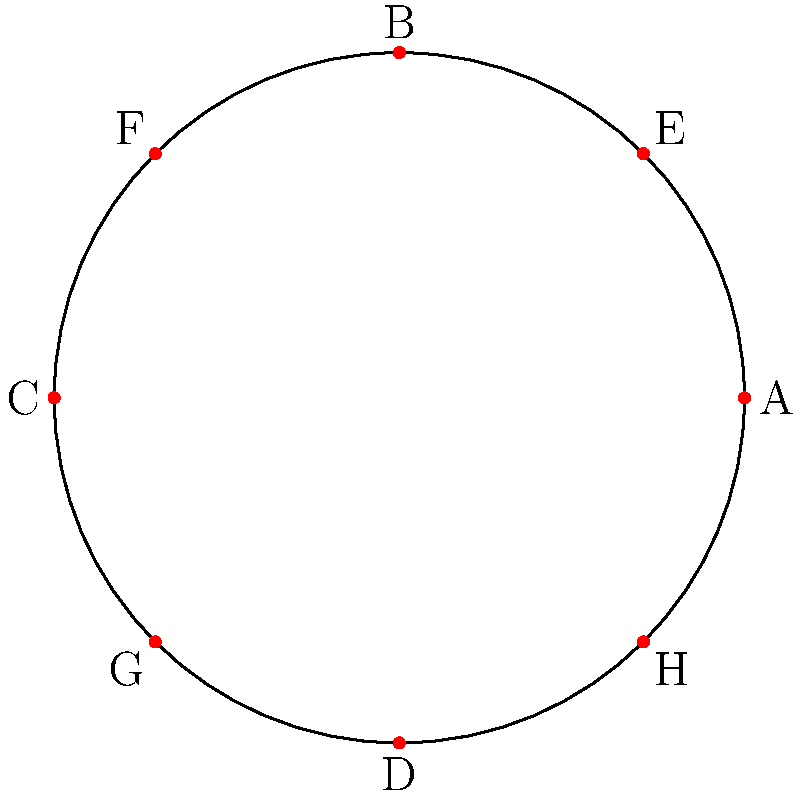In a circular city district with a radius of 5 km, eight polling stations are placed as shown in the diagram. The stations are located at points A, B, C, D, E, F, G, and H. If the polar coordinates of station E are $(r, \theta)$, what is the value of $\theta$ in radians? To solve this problem, let's follow these steps:

1) First, we need to understand what polar coordinates are. In polar coordinates, a point is described by its distance from the origin (r) and the angle ($\theta$) from the positive x-axis.

2) We're given that the radius of the circle is 5 km, so $r = 5$ for all points on the circle.

3) Looking at the diagram, we can see that point E is in the first quadrant, and it appears to be halfway between the positive x-axis and the positive y-axis.

4) In a full circle, there are $2\pi$ radians. A quarter of a circle (90 degrees) is therefore $\frac{\pi}{2}$ radians.

5) Since E is halfway between 0 and $\frac{\pi}{2}$, its angle must be half of $\frac{\pi}{2}$.

6) We can calculate this as:

   $$\theta = \frac{1}{2} \cdot \frac{\pi}{2} = \frac{\pi}{4}$$

7) We can verify this by noting that the x and y coordinates of E appear to be equal and positive, which is consistent with an angle of $\frac{\pi}{4}$.

Therefore, the polar coordinates of station E are $(5, \frac{\pi}{4})$.
Answer: $\frac{\pi}{4}$ radians 